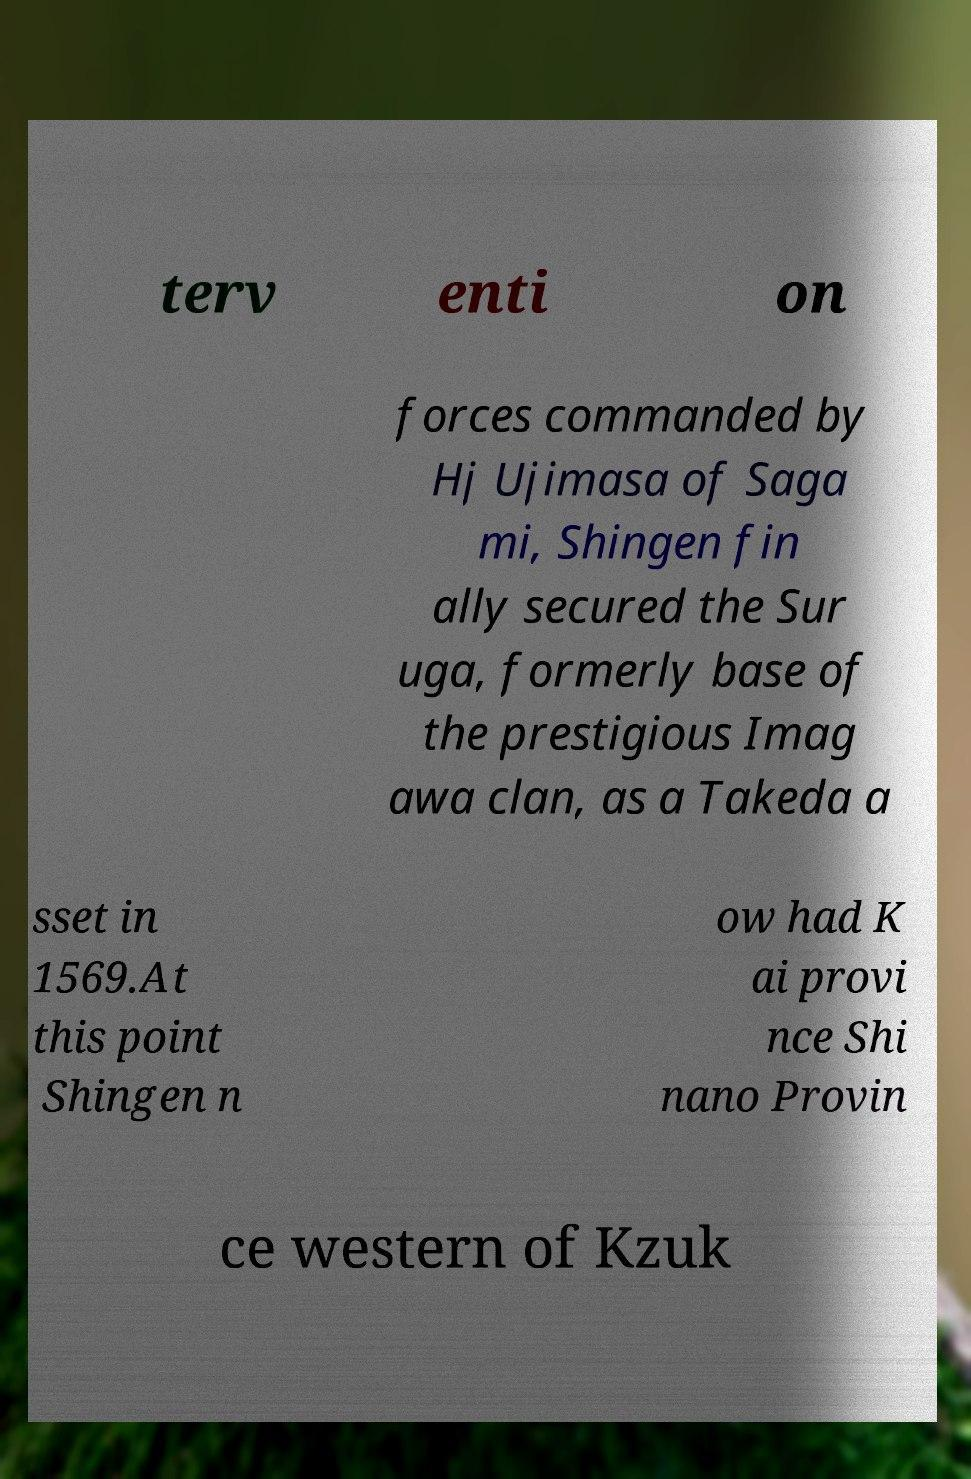There's text embedded in this image that I need extracted. Can you transcribe it verbatim? terv enti on forces commanded by Hj Ujimasa of Saga mi, Shingen fin ally secured the Sur uga, formerly base of the prestigious Imag awa clan, as a Takeda a sset in 1569.At this point Shingen n ow had K ai provi nce Shi nano Provin ce western of Kzuk 